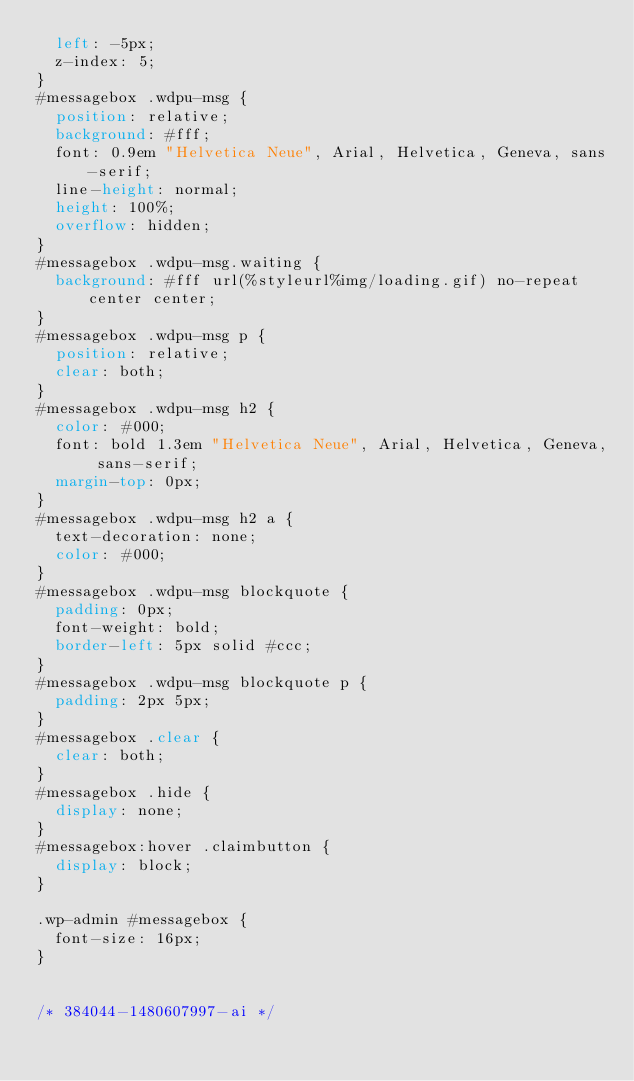Convert code to text. <code><loc_0><loc_0><loc_500><loc_500><_CSS_>  left: -5px;
  z-index: 5;
}
#messagebox .wdpu-msg {
  position: relative;
  background: #fff;
  font: 0.9em "Helvetica Neue", Arial, Helvetica, Geneva, sans-serif;
  line-height: normal;
  height: 100%;
  overflow: hidden;
}
#messagebox .wdpu-msg.waiting {
  background: #fff url(%styleurl%img/loading.gif) no-repeat center center;
}
#messagebox .wdpu-msg p {
  position: relative;
  clear: both;
}
#messagebox .wdpu-msg h2 {
  color: #000;
  font: bold 1.3em "Helvetica Neue", Arial, Helvetica, Geneva, sans-serif;
  margin-top: 0px;
}
#messagebox .wdpu-msg h2 a {
  text-decoration: none;
  color: #000;
}
#messagebox .wdpu-msg blockquote {
  padding: 0px;
  font-weight: bold;
  border-left: 5px solid #ccc;
}
#messagebox .wdpu-msg blockquote p {
  padding: 2px 5px;
}
#messagebox .clear {
  clear: both;
}
#messagebox .hide {
  display: none;
}
#messagebox:hover .claimbutton {
  display: block;
}

.wp-admin #messagebox {
  font-size: 16px;
}


/* 384044-1480607997-ai */</code> 